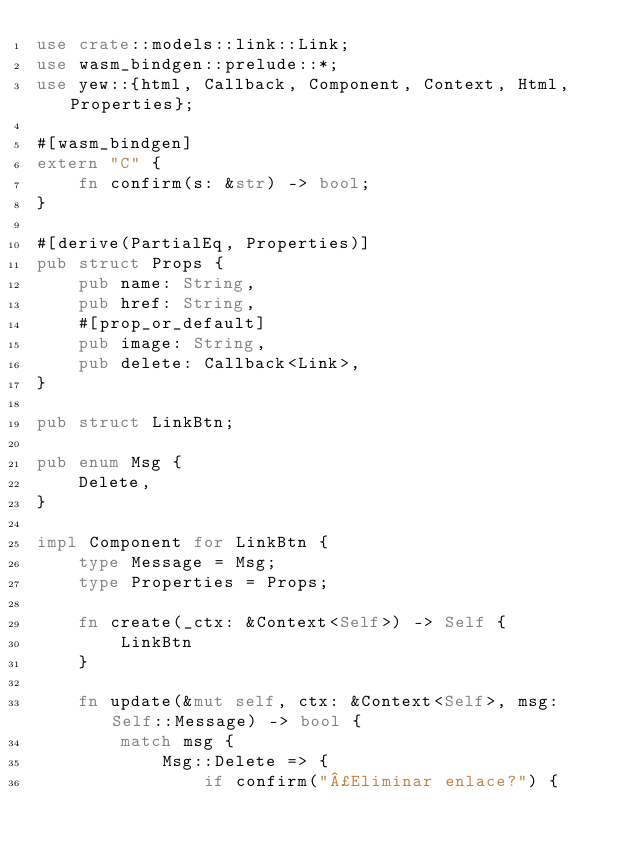<code> <loc_0><loc_0><loc_500><loc_500><_Rust_>use crate::models::link::Link;
use wasm_bindgen::prelude::*;
use yew::{html, Callback, Component, Context, Html, Properties};

#[wasm_bindgen]
extern "C" {
    fn confirm(s: &str) -> bool;
}

#[derive(PartialEq, Properties)]
pub struct Props {
    pub name: String,
    pub href: String,
    #[prop_or_default]
    pub image: String,
    pub delete: Callback<Link>,
}

pub struct LinkBtn;

pub enum Msg {
    Delete,
}

impl Component for LinkBtn {
    type Message = Msg;
    type Properties = Props;

    fn create(_ctx: &Context<Self>) -> Self {
        LinkBtn
    }

    fn update(&mut self, ctx: &Context<Self>, msg: Self::Message) -> bool {
        match msg {
            Msg::Delete => {
                if confirm("¿Eliminar enlace?") {</code> 